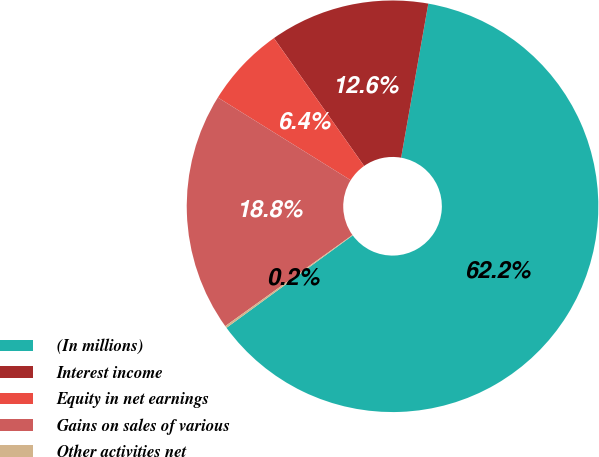<chart> <loc_0><loc_0><loc_500><loc_500><pie_chart><fcel>(In millions)<fcel>Interest income<fcel>Equity in net earnings<fcel>Gains on sales of various<fcel>Other activities net<nl><fcel>62.17%<fcel>12.56%<fcel>6.36%<fcel>18.76%<fcel>0.16%<nl></chart> 